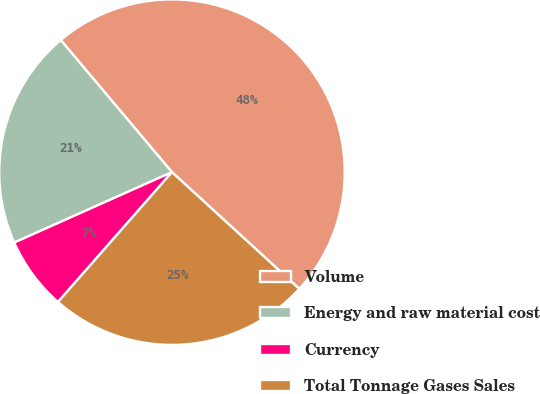Convert chart to OTSL. <chart><loc_0><loc_0><loc_500><loc_500><pie_chart><fcel>Volume<fcel>Energy and raw material cost<fcel>Currency<fcel>Total Tonnage Gases Sales<nl><fcel>47.95%<fcel>20.55%<fcel>6.85%<fcel>24.66%<nl></chart> 